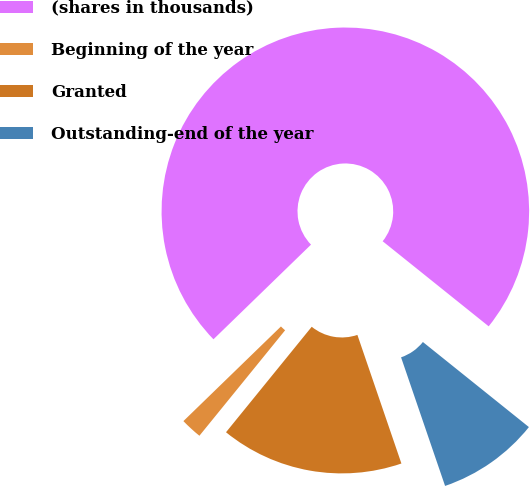Convert chart to OTSL. <chart><loc_0><loc_0><loc_500><loc_500><pie_chart><fcel>(shares in thousands)<fcel>Beginning of the year<fcel>Granted<fcel>Outstanding-end of the year<nl><fcel>73.03%<fcel>1.88%<fcel>16.11%<fcel>8.99%<nl></chart> 